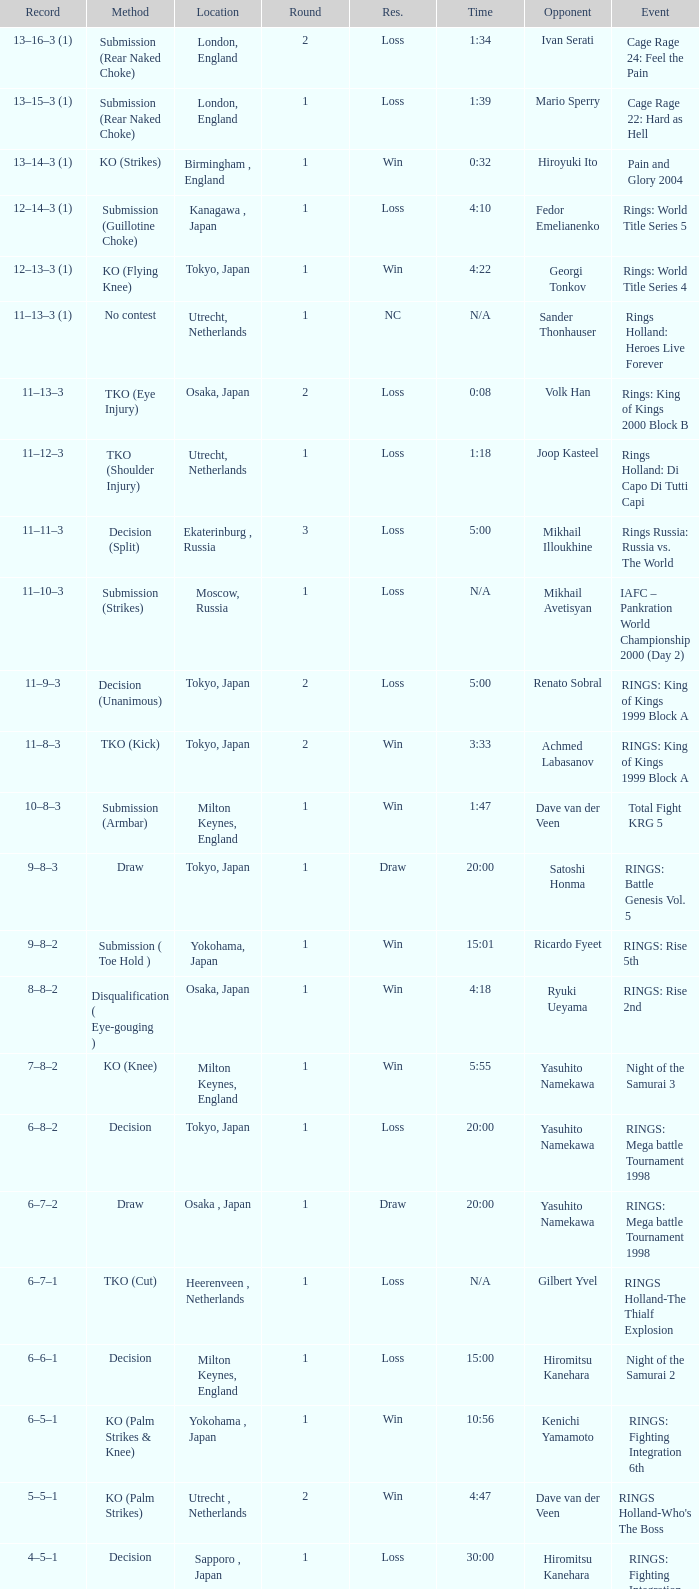Who was the opponent in London, England in a round less than 2? Mario Sperry. 